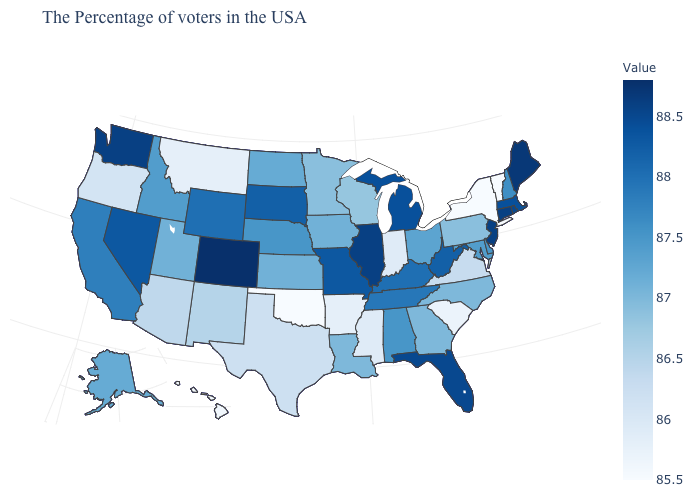Which states have the highest value in the USA?
Short answer required. Colorado. Which states have the lowest value in the MidWest?
Keep it brief. Indiana. Does North Dakota have a lower value than Oregon?
Quick response, please. No. Is the legend a continuous bar?
Quick response, please. Yes. Does Georgia have a lower value than Kentucky?
Short answer required. Yes. Among the states that border Nevada , which have the lowest value?
Quick response, please. Oregon. 